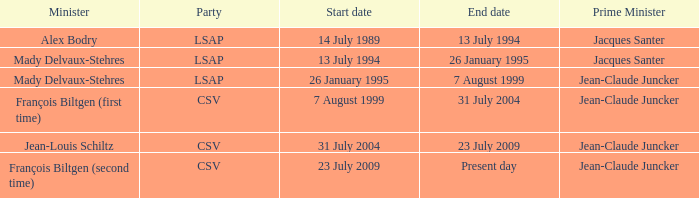What was the termination date when alex bodry was in the minister role? 13 July 1994. 